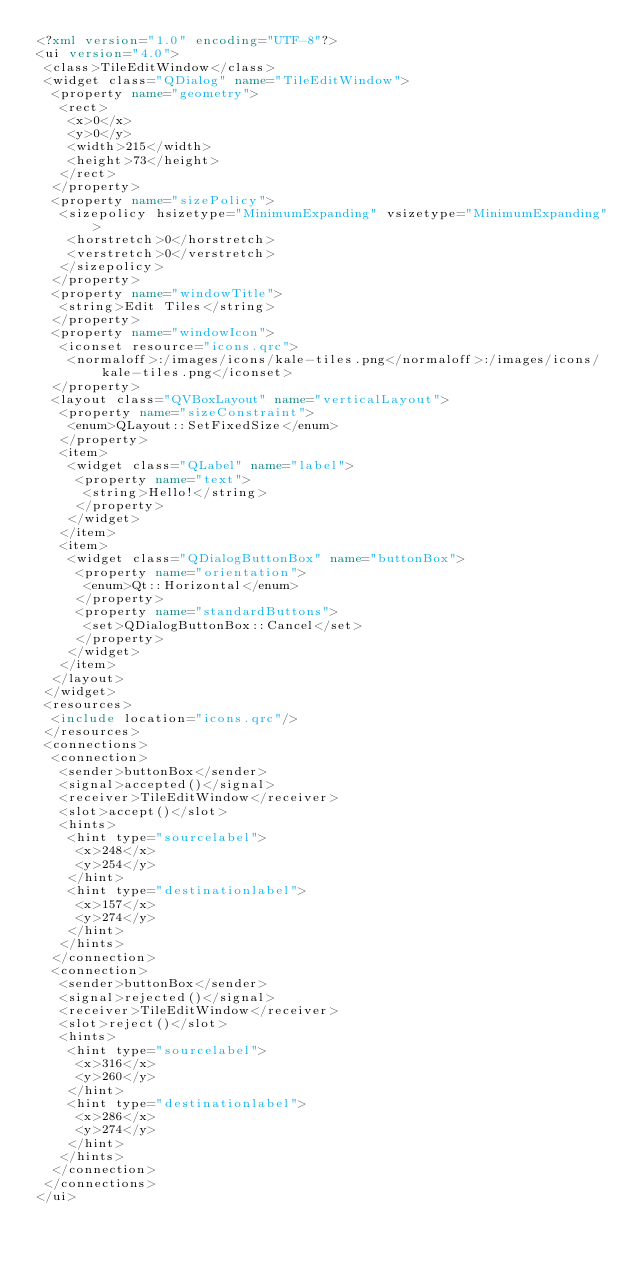Convert code to text. <code><loc_0><loc_0><loc_500><loc_500><_XML_><?xml version="1.0" encoding="UTF-8"?>
<ui version="4.0">
 <class>TileEditWindow</class>
 <widget class="QDialog" name="TileEditWindow">
  <property name="geometry">
   <rect>
    <x>0</x>
    <y>0</y>
    <width>215</width>
    <height>73</height>
   </rect>
  </property>
  <property name="sizePolicy">
   <sizepolicy hsizetype="MinimumExpanding" vsizetype="MinimumExpanding">
    <horstretch>0</horstretch>
    <verstretch>0</verstretch>
   </sizepolicy>
  </property>
  <property name="windowTitle">
   <string>Edit Tiles</string>
  </property>
  <property name="windowIcon">
   <iconset resource="icons.qrc">
    <normaloff>:/images/icons/kale-tiles.png</normaloff>:/images/icons/kale-tiles.png</iconset>
  </property>
  <layout class="QVBoxLayout" name="verticalLayout">
   <property name="sizeConstraint">
    <enum>QLayout::SetFixedSize</enum>
   </property>
   <item>
    <widget class="QLabel" name="label">
     <property name="text">
      <string>Hello!</string>
     </property>
    </widget>
   </item>
   <item>
    <widget class="QDialogButtonBox" name="buttonBox">
     <property name="orientation">
      <enum>Qt::Horizontal</enum>
     </property>
     <property name="standardButtons">
      <set>QDialogButtonBox::Cancel</set>
     </property>
    </widget>
   </item>
  </layout>
 </widget>
 <resources>
  <include location="icons.qrc"/>
 </resources>
 <connections>
  <connection>
   <sender>buttonBox</sender>
   <signal>accepted()</signal>
   <receiver>TileEditWindow</receiver>
   <slot>accept()</slot>
   <hints>
    <hint type="sourcelabel">
     <x>248</x>
     <y>254</y>
    </hint>
    <hint type="destinationlabel">
     <x>157</x>
     <y>274</y>
    </hint>
   </hints>
  </connection>
  <connection>
   <sender>buttonBox</sender>
   <signal>rejected()</signal>
   <receiver>TileEditWindow</receiver>
   <slot>reject()</slot>
   <hints>
    <hint type="sourcelabel">
     <x>316</x>
     <y>260</y>
    </hint>
    <hint type="destinationlabel">
     <x>286</x>
     <y>274</y>
    </hint>
   </hints>
  </connection>
 </connections>
</ui>
</code> 